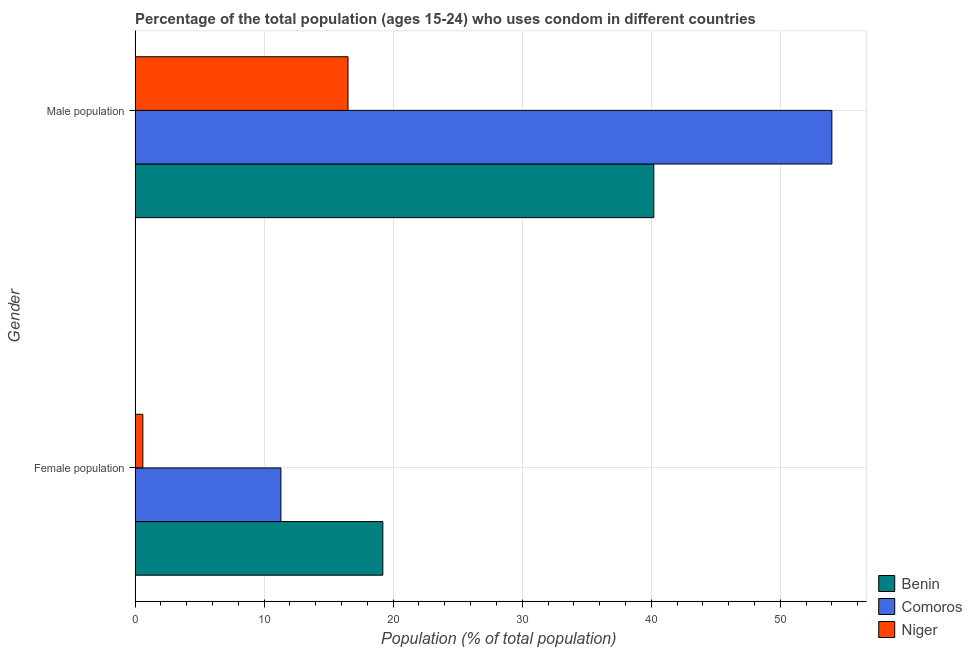How many different coloured bars are there?
Offer a very short reply. 3. How many groups of bars are there?
Your response must be concise. 2. What is the label of the 1st group of bars from the top?
Your answer should be compact. Male population. What is the female population in Benin?
Ensure brevity in your answer.  19.2. In which country was the male population maximum?
Offer a terse response. Comoros. In which country was the male population minimum?
Keep it short and to the point. Niger. What is the total male population in the graph?
Provide a succinct answer. 110.7. What is the difference between the female population in Niger and that in Benin?
Make the answer very short. -18.6. What is the difference between the male population in Comoros and the female population in Benin?
Your answer should be compact. 34.8. What is the average female population per country?
Keep it short and to the point. 10.37. What is the difference between the male population and female population in Comoros?
Make the answer very short. 42.7. What is the ratio of the male population in Niger to that in Comoros?
Your response must be concise. 0.31. In how many countries, is the female population greater than the average female population taken over all countries?
Make the answer very short. 2. What does the 2nd bar from the top in Female population represents?
Provide a short and direct response. Comoros. What does the 1st bar from the bottom in Female population represents?
Give a very brief answer. Benin. How many bars are there?
Provide a short and direct response. 6. What is the difference between two consecutive major ticks on the X-axis?
Keep it short and to the point. 10. Are the values on the major ticks of X-axis written in scientific E-notation?
Your answer should be compact. No. Does the graph contain any zero values?
Ensure brevity in your answer.  No. How are the legend labels stacked?
Ensure brevity in your answer.  Vertical. What is the title of the graph?
Provide a short and direct response. Percentage of the total population (ages 15-24) who uses condom in different countries. Does "American Samoa" appear as one of the legend labels in the graph?
Make the answer very short. No. What is the label or title of the X-axis?
Give a very brief answer. Population (% of total population) . What is the label or title of the Y-axis?
Give a very brief answer. Gender. What is the Population (% of total population)  of Benin in Female population?
Your answer should be compact. 19.2. What is the Population (% of total population)  in Comoros in Female population?
Your response must be concise. 11.3. What is the Population (% of total population)  in Niger in Female population?
Your response must be concise. 0.6. What is the Population (% of total population)  of Benin in Male population?
Your answer should be very brief. 40.2. What is the Population (% of total population)  in Comoros in Male population?
Give a very brief answer. 54. What is the Population (% of total population)  of Niger in Male population?
Provide a succinct answer. 16.5. Across all Gender, what is the maximum Population (% of total population)  of Benin?
Offer a terse response. 40.2. Across all Gender, what is the maximum Population (% of total population)  of Niger?
Your response must be concise. 16.5. Across all Gender, what is the minimum Population (% of total population)  in Niger?
Provide a succinct answer. 0.6. What is the total Population (% of total population)  in Benin in the graph?
Provide a succinct answer. 59.4. What is the total Population (% of total population)  of Comoros in the graph?
Keep it short and to the point. 65.3. What is the total Population (% of total population)  of Niger in the graph?
Ensure brevity in your answer.  17.1. What is the difference between the Population (% of total population)  of Comoros in Female population and that in Male population?
Ensure brevity in your answer.  -42.7. What is the difference between the Population (% of total population)  of Niger in Female population and that in Male population?
Offer a terse response. -15.9. What is the difference between the Population (% of total population)  of Benin in Female population and the Population (% of total population)  of Comoros in Male population?
Your answer should be very brief. -34.8. What is the difference between the Population (% of total population)  of Benin in Female population and the Population (% of total population)  of Niger in Male population?
Provide a succinct answer. 2.7. What is the average Population (% of total population)  of Benin per Gender?
Your response must be concise. 29.7. What is the average Population (% of total population)  of Comoros per Gender?
Offer a terse response. 32.65. What is the average Population (% of total population)  of Niger per Gender?
Provide a short and direct response. 8.55. What is the difference between the Population (% of total population)  of Benin and Population (% of total population)  of Comoros in Female population?
Offer a very short reply. 7.9. What is the difference between the Population (% of total population)  in Benin and Population (% of total population)  in Niger in Female population?
Your answer should be very brief. 18.6. What is the difference between the Population (% of total population)  of Comoros and Population (% of total population)  of Niger in Female population?
Your response must be concise. 10.7. What is the difference between the Population (% of total population)  of Benin and Population (% of total population)  of Niger in Male population?
Offer a very short reply. 23.7. What is the difference between the Population (% of total population)  of Comoros and Population (% of total population)  of Niger in Male population?
Give a very brief answer. 37.5. What is the ratio of the Population (% of total population)  in Benin in Female population to that in Male population?
Your response must be concise. 0.48. What is the ratio of the Population (% of total population)  in Comoros in Female population to that in Male population?
Offer a terse response. 0.21. What is the ratio of the Population (% of total population)  of Niger in Female population to that in Male population?
Your answer should be very brief. 0.04. What is the difference between the highest and the second highest Population (% of total population)  in Benin?
Provide a succinct answer. 21. What is the difference between the highest and the second highest Population (% of total population)  in Comoros?
Ensure brevity in your answer.  42.7. What is the difference between the highest and the second highest Population (% of total population)  of Niger?
Your response must be concise. 15.9. What is the difference between the highest and the lowest Population (% of total population)  in Comoros?
Offer a terse response. 42.7. 